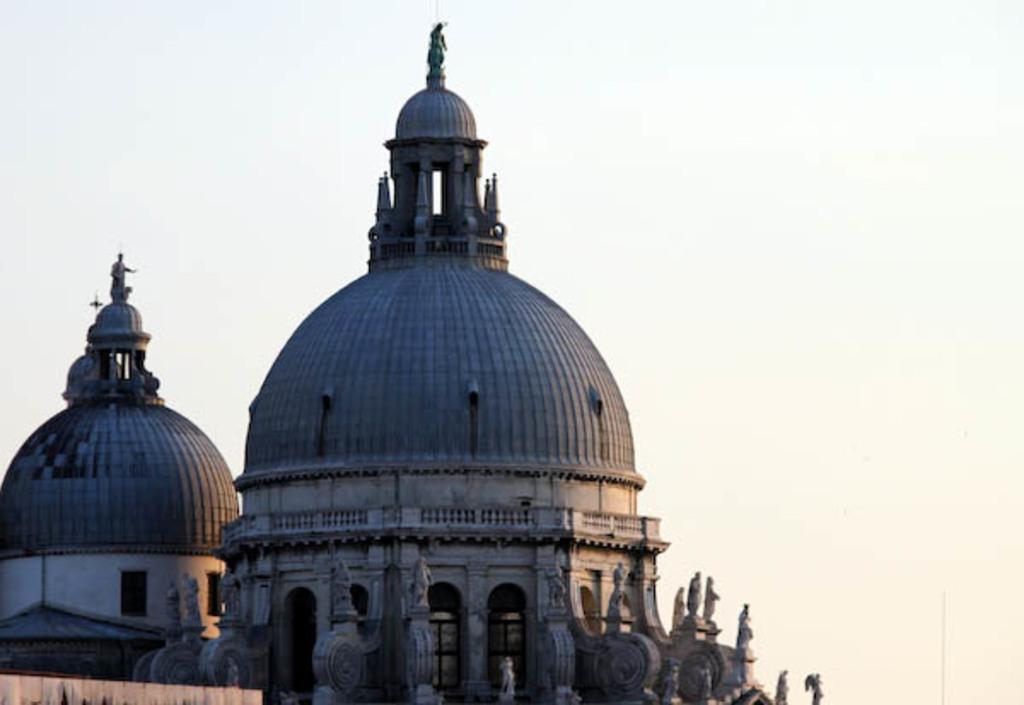Could you give a brief overview of what you see in this image? In this image there are two tombs at left side of this image and there is a sky in the background. 